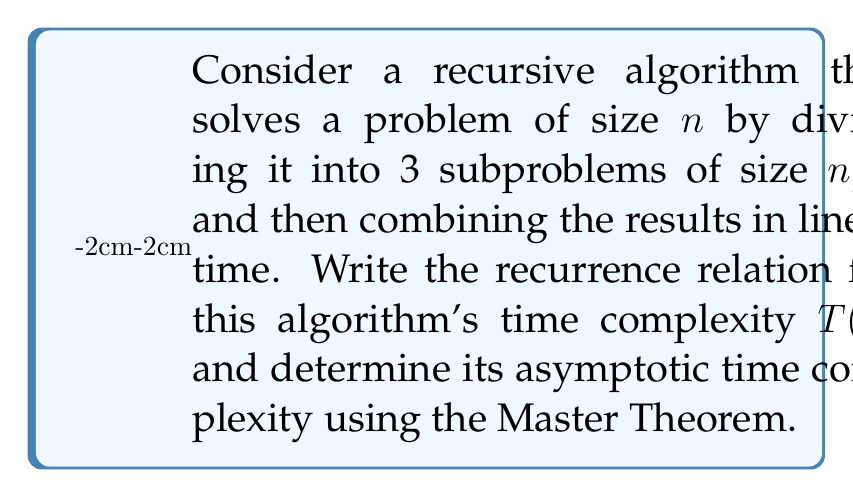Teach me how to tackle this problem. 1. First, let's write the recurrence relation:
   $$T(n) = 3T(\frac{n}{2}) + cn$$
   where c is a constant representing the linear time for combining results.

2. To apply the Master Theorem, we need to identify a, b, and f(n):
   - a = 3 (number of subproblems)
   - b = 2 (factor by which the problem size is reduced)
   - f(n) = cn (work done outside the recursive calls)

3. The Master Theorem states:
   $$T(n) = aT(\frac{n}{b}) + f(n)$$
   $$\text{If } f(n) = \Theta(n^d) \text{ where } d \geq 0$$

4. Compare $n^{\log_b a}$ with $f(n)$:
   $$n^{\log_b a} = n^{\log_2 3} \approx n^{1.58}$$
   $$f(n) = cn = \Theta(n)$$

5. Since $n^{\log_2 3} > n$, we fall into case 1 of the Master Theorem:
   If $f(n) = O(n^{\log_b a - \epsilon})$ for some constant $\epsilon > 0$,
   then $T(n) = \Theta(n^{\log_b a})$

6. We can verify that $n = O(n^{\log_2 3 - \epsilon})$ for $\epsilon = 0.58$

7. Therefore, the asymptotic time complexity is:
   $$T(n) = \Theta(n^{\log_2 3}) \approx \Theta(n^{1.58})$$
Answer: $\Theta(n^{\log_2 3})$ 